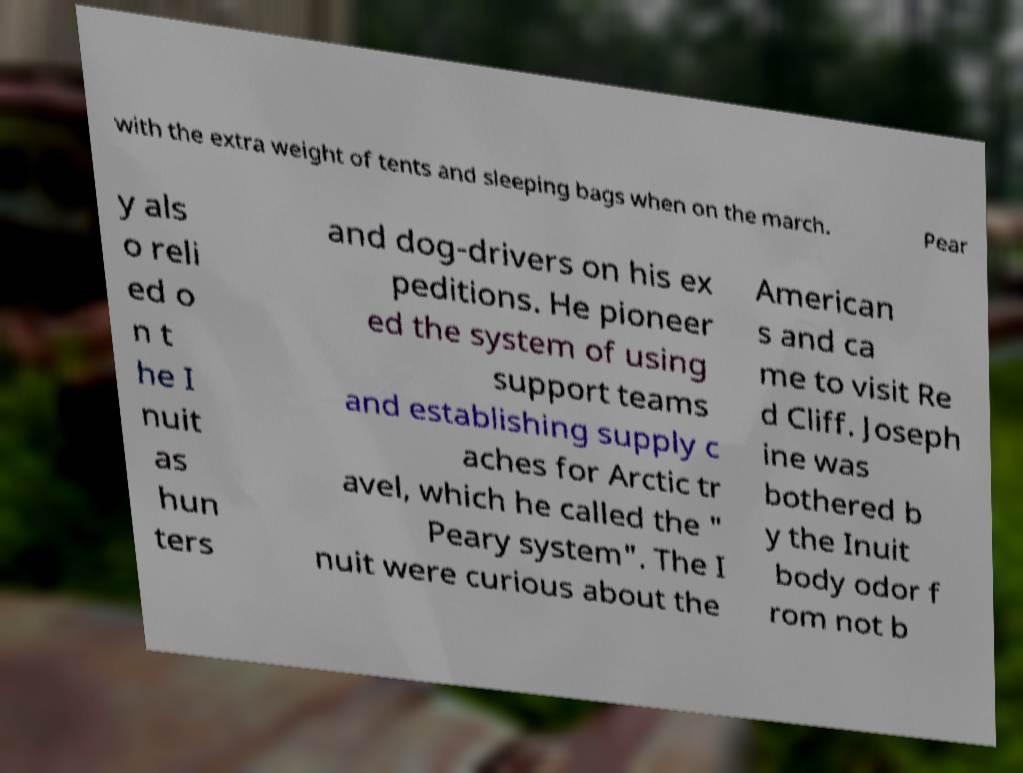Could you assist in decoding the text presented in this image and type it out clearly? with the extra weight of tents and sleeping bags when on the march. Pear y als o reli ed o n t he I nuit as hun ters and dog-drivers on his ex peditions. He pioneer ed the system of using support teams and establishing supply c aches for Arctic tr avel, which he called the " Peary system". The I nuit were curious about the American s and ca me to visit Re d Cliff. Joseph ine was bothered b y the Inuit body odor f rom not b 